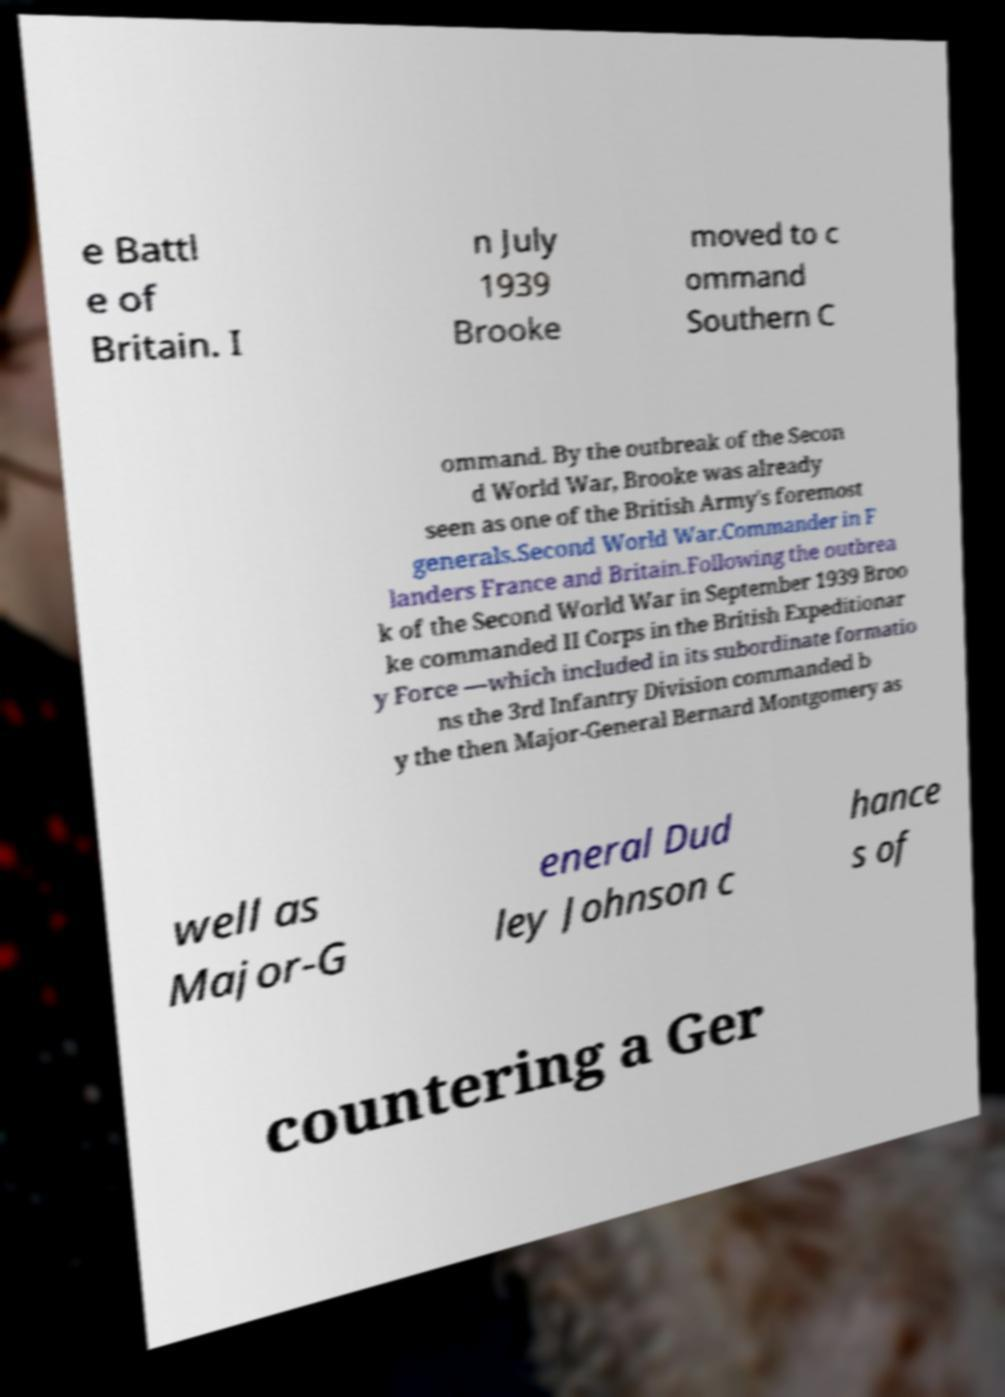There's text embedded in this image that I need extracted. Can you transcribe it verbatim? e Battl e of Britain. I n July 1939 Brooke moved to c ommand Southern C ommand. By the outbreak of the Secon d World War, Brooke was already seen as one of the British Army's foremost generals.Second World War.Commander in F landers France and Britain.Following the outbrea k of the Second World War in September 1939 Broo ke commanded II Corps in the British Expeditionar y Force —which included in its subordinate formatio ns the 3rd Infantry Division commanded b y the then Major-General Bernard Montgomery as well as Major-G eneral Dud ley Johnson c hance s of countering a Ger 